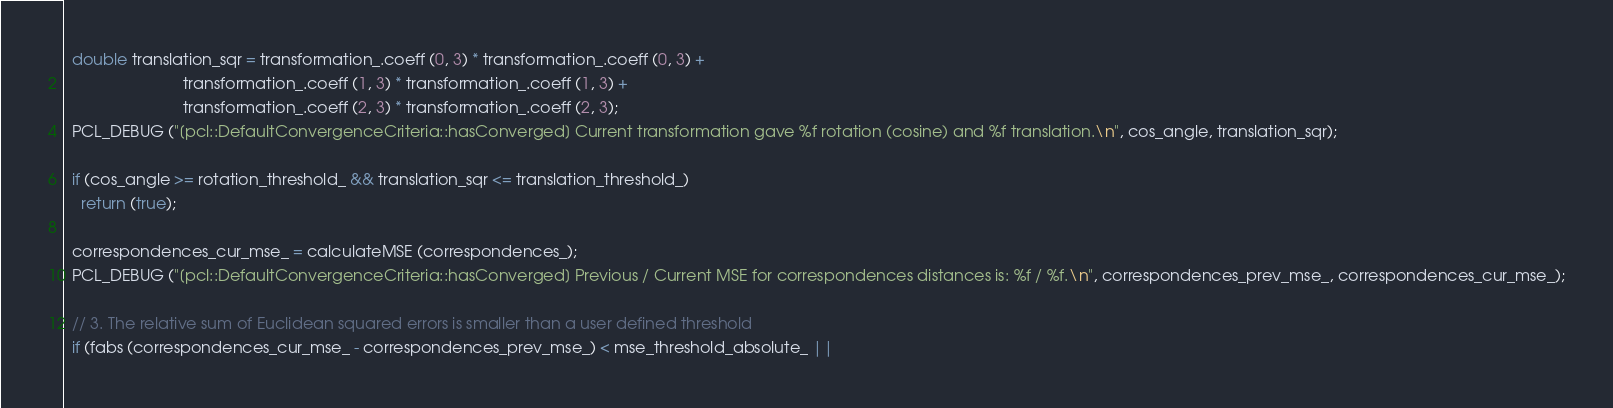<code> <loc_0><loc_0><loc_500><loc_500><_C++_>  double translation_sqr = transformation_.coeff (0, 3) * transformation_.coeff (0, 3) +
                           transformation_.coeff (1, 3) * transformation_.coeff (1, 3) +
                           transformation_.coeff (2, 3) * transformation_.coeff (2, 3);
  PCL_DEBUG ("[pcl::DefaultConvergenceCriteria::hasConverged] Current transformation gave %f rotation (cosine) and %f translation.\n", cos_angle, translation_sqr);

  if (cos_angle >= rotation_threshold_ && translation_sqr <= translation_threshold_)
    return (true);

  correspondences_cur_mse_ = calculateMSE (correspondences_);
  PCL_DEBUG ("[pcl::DefaultConvergenceCriteria::hasConverged] Previous / Current MSE for correspondences distances is: %f / %f.\n", correspondences_prev_mse_, correspondences_cur_mse_);

  // 3. The relative sum of Euclidean squared errors is smaller than a user defined threshold
  if (fabs (correspondences_cur_mse_ - correspondences_prev_mse_) < mse_threshold_absolute_ ||</code> 